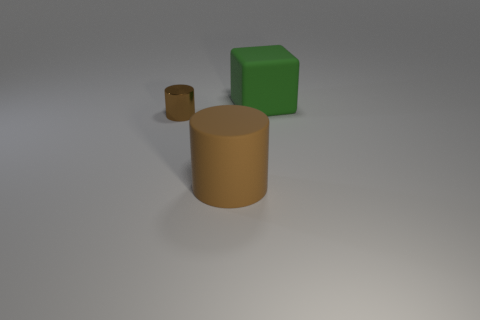Add 1 large cubes. How many objects exist? 4 Subtract all cylinders. How many objects are left? 1 Add 3 brown metal cylinders. How many brown metal cylinders are left? 4 Add 3 large brown cylinders. How many large brown cylinders exist? 4 Subtract 0 brown balls. How many objects are left? 3 Subtract all big cyan objects. Subtract all large green rubber cubes. How many objects are left? 2 